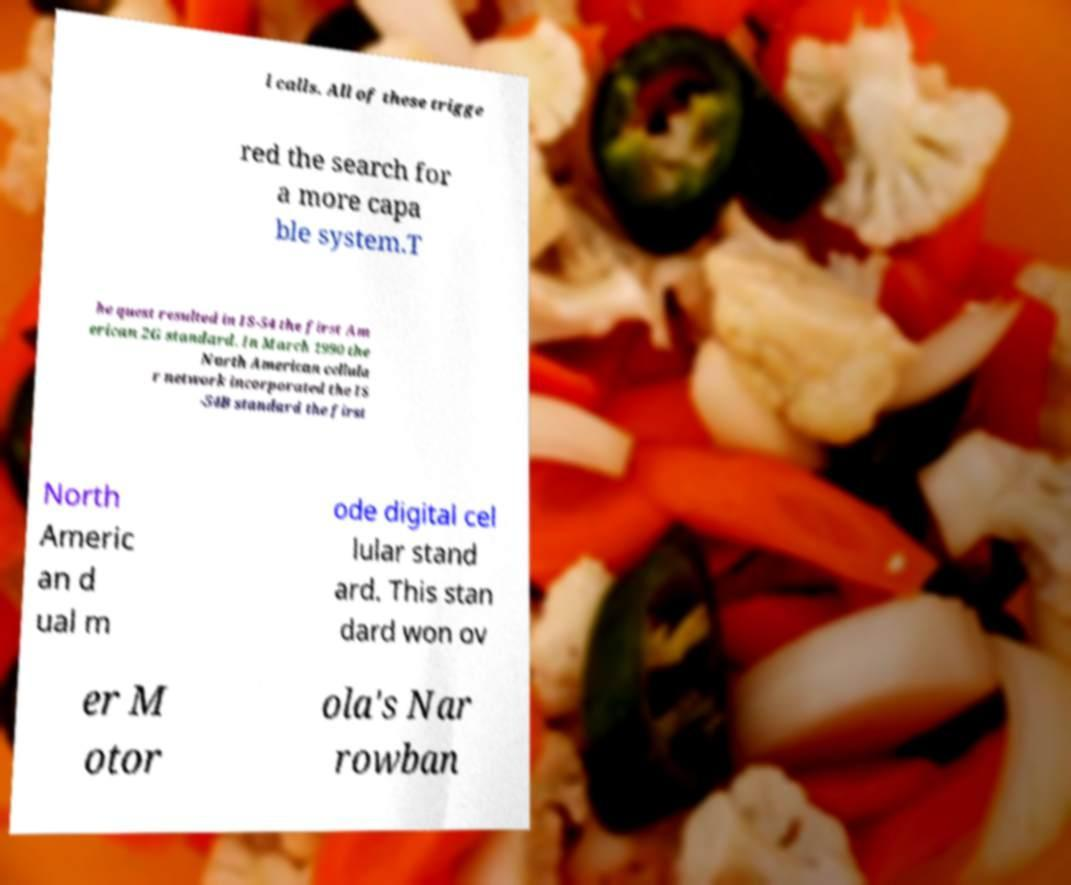What messages or text are displayed in this image? I need them in a readable, typed format. l calls. All of these trigge red the search for a more capa ble system.T he quest resulted in IS-54 the first Am erican 2G standard. In March 1990 the North American cellula r network incorporated the IS -54B standard the first North Americ an d ual m ode digital cel lular stand ard. This stan dard won ov er M otor ola's Nar rowban 